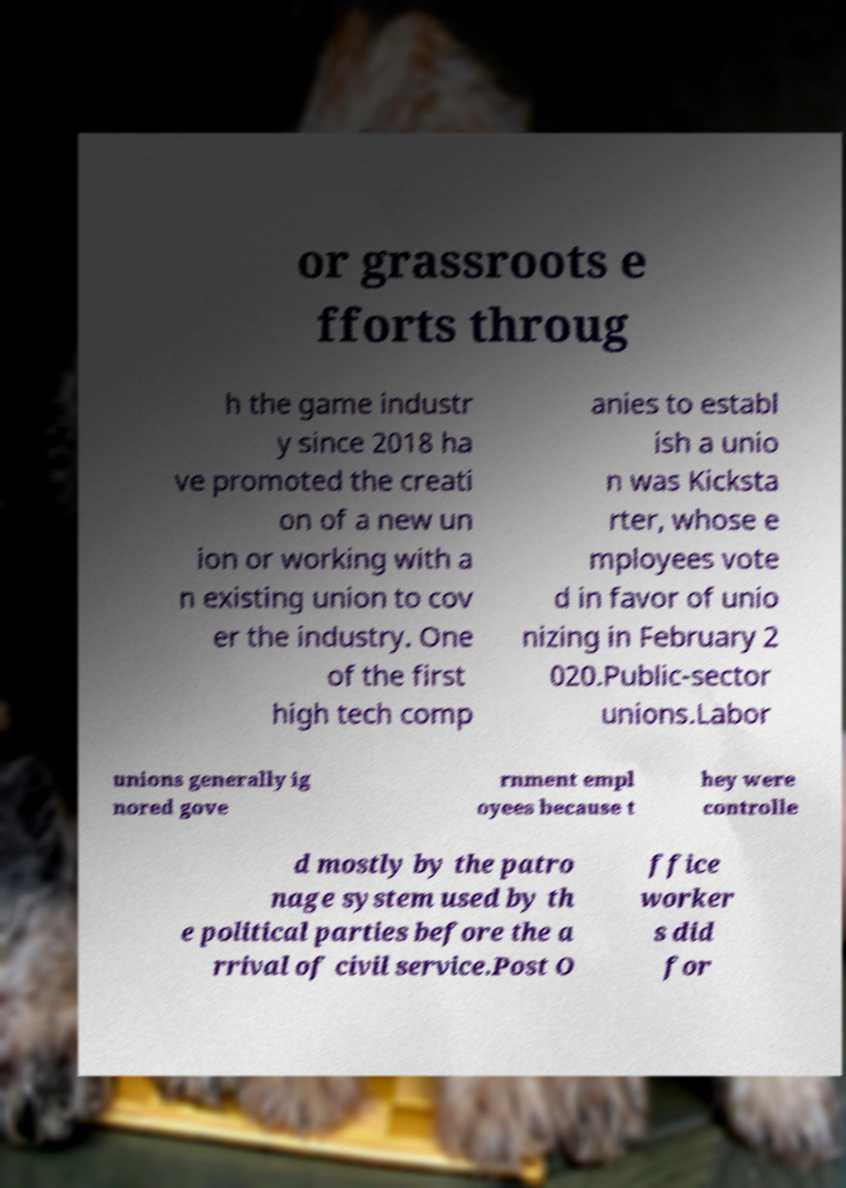Could you extract and type out the text from this image? or grassroots e fforts throug h the game industr y since 2018 ha ve promoted the creati on of a new un ion or working with a n existing union to cov er the industry. One of the first high tech comp anies to establ ish a unio n was Kicksta rter, whose e mployees vote d in favor of unio nizing in February 2 020.Public-sector unions.Labor unions generally ig nored gove rnment empl oyees because t hey were controlle d mostly by the patro nage system used by th e political parties before the a rrival of civil service.Post O ffice worker s did for 